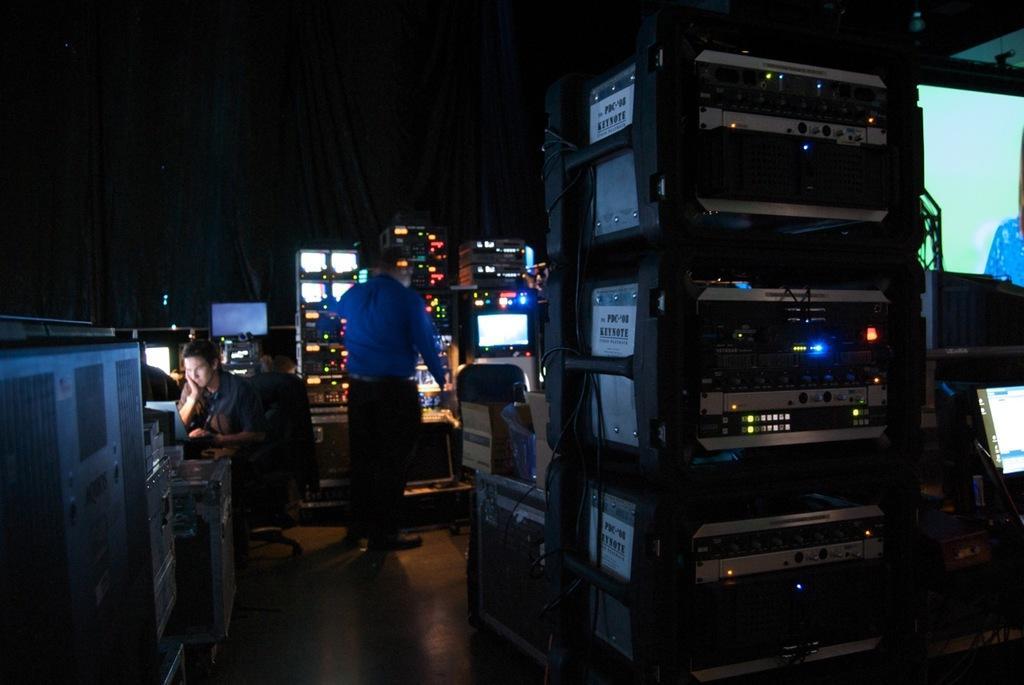Describe this image in one or two sentences. In this image we can see a few electronic devices, and two people in the room, a person is sitting and a person is standing and a screen on the right side of the picture. 